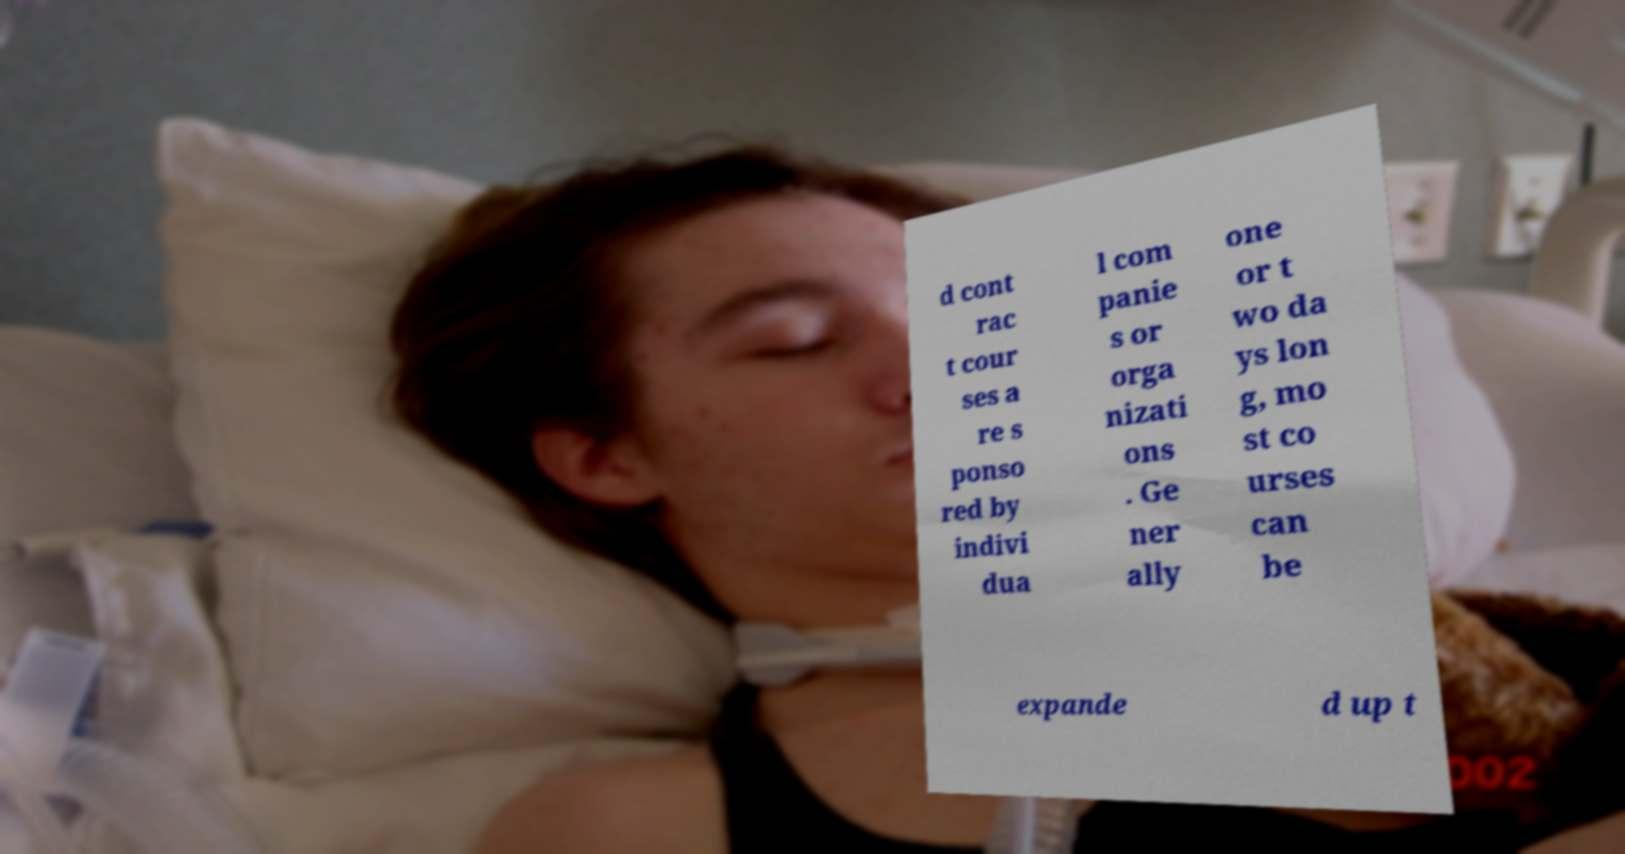I need the written content from this picture converted into text. Can you do that? d cont rac t cour ses a re s ponso red by indivi dua l com panie s or orga nizati ons . Ge ner ally one or t wo da ys lon g, mo st co urses can be expande d up t 